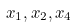<formula> <loc_0><loc_0><loc_500><loc_500>x _ { 1 } , x _ { 2 } , x _ { 4 }</formula> 